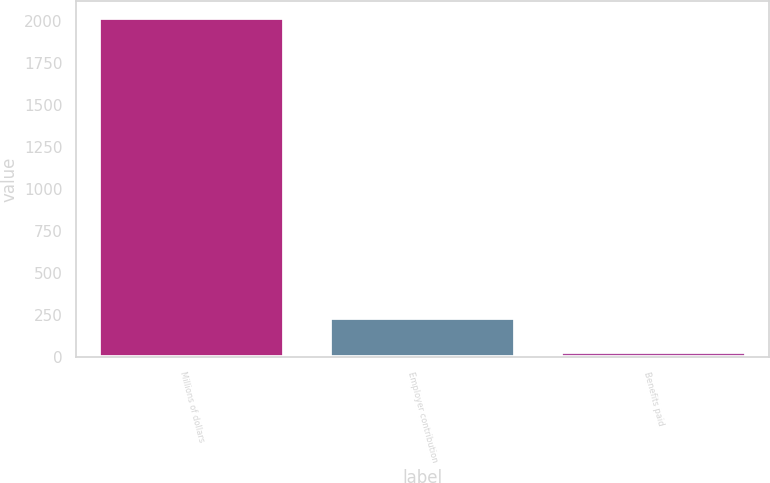Convert chart. <chart><loc_0><loc_0><loc_500><loc_500><bar_chart><fcel>Millions of dollars<fcel>Employer contribution<fcel>Benefits paid<nl><fcel>2018<fcel>229.7<fcel>31<nl></chart> 